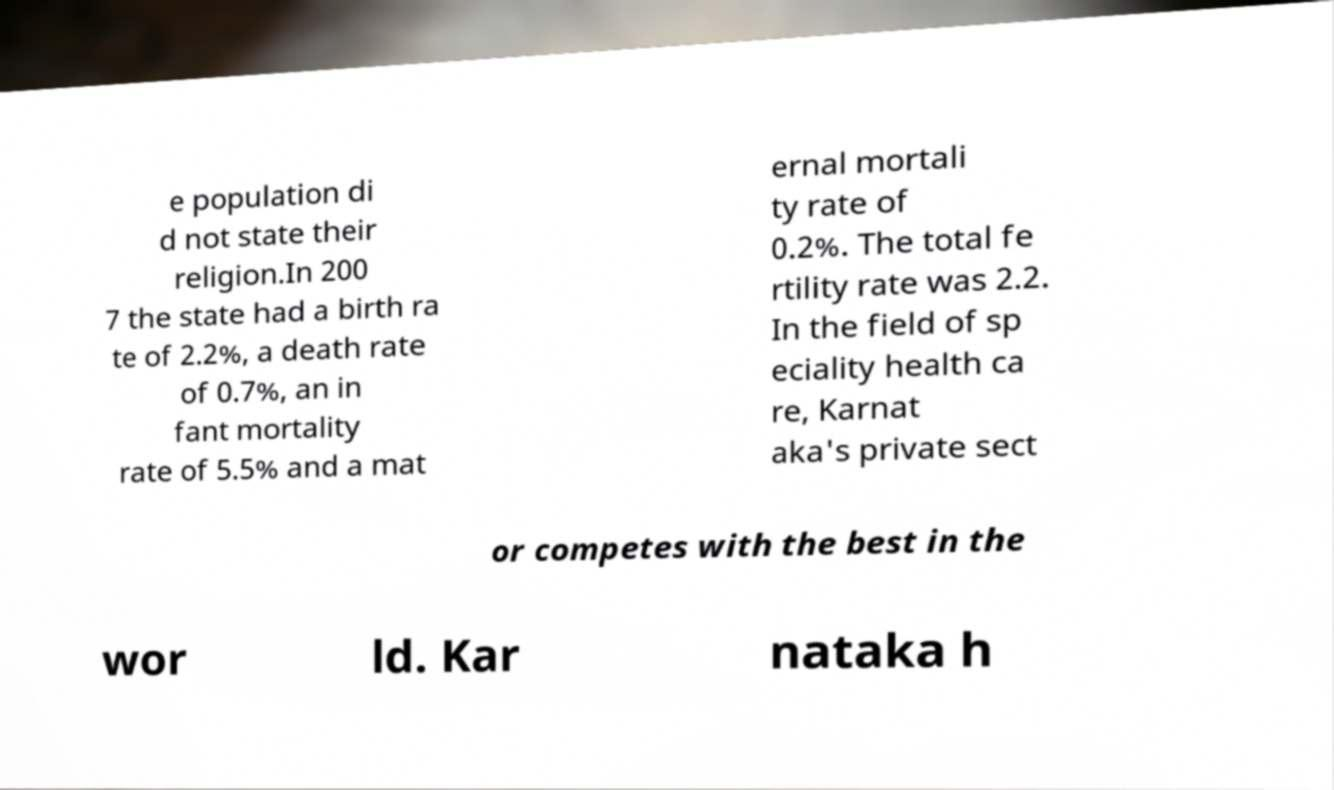For documentation purposes, I need the text within this image transcribed. Could you provide that? e population di d not state their religion.In 200 7 the state had a birth ra te of 2.2%, a death rate of 0.7%, an in fant mortality rate of 5.5% and a mat ernal mortali ty rate of 0.2%. The total fe rtility rate was 2.2. In the field of sp eciality health ca re, Karnat aka's private sect or competes with the best in the wor ld. Kar nataka h 